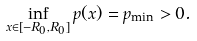<formula> <loc_0><loc_0><loc_500><loc_500>\inf _ { x \in [ - R _ { 0 } , R _ { 0 } ] } p ( x ) = p _ { \min } > 0 .</formula> 